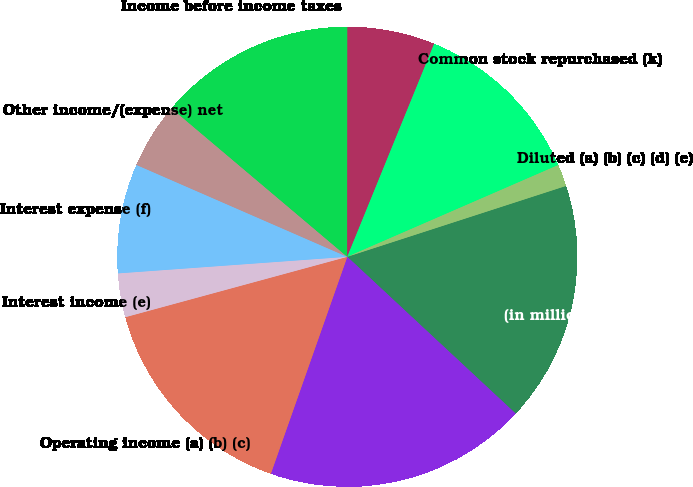Convert chart to OTSL. <chart><loc_0><loc_0><loc_500><loc_500><pie_chart><fcel>(in millions except per share<fcel>Operating expenses (b) (c) (d)<fcel>Operating income (a) (b) (c)<fcel>Interest income (e)<fcel>Interest expense (f)<fcel>Other income/(expense) net<fcel>Income before income taxes<fcel>Capital expenditures (j)<fcel>Common stock repurchased (k)<fcel>Diluted (a) (b) (c) (d) (e)<nl><fcel>16.92%<fcel>18.46%<fcel>15.38%<fcel>3.08%<fcel>7.69%<fcel>4.62%<fcel>13.85%<fcel>6.15%<fcel>12.31%<fcel>1.54%<nl></chart> 